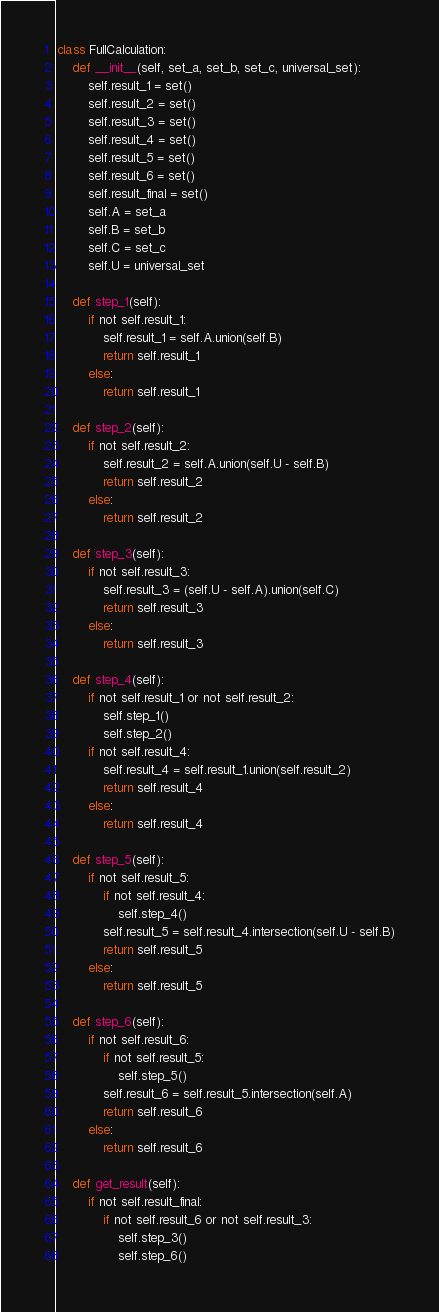Convert code to text. <code><loc_0><loc_0><loc_500><loc_500><_Python_>class FullCalculation:
    def __init__(self, set_a, set_b, set_c, universal_set):
        self.result_1 = set()
        self.result_2 = set()
        self.result_3 = set()
        self.result_4 = set()
        self.result_5 = set()
        self.result_6 = set()
        self.result_final = set()
        self.A = set_a
        self.B = set_b
        self.C = set_c
        self.U = universal_set

    def step_1(self):
        if not self.result_1:
            self.result_1 = self.A.union(self.B)
            return self.result_1
        else:
            return self.result_1

    def step_2(self):
        if not self.result_2:
            self.result_2 = self.A.union(self.U - self.B)
            return self.result_2
        else:
            return self.result_2

    def step_3(self):
        if not self.result_3:
            self.result_3 = (self.U - self.A).union(self.C)
            return self.result_3
        else:
            return self.result_3

    def step_4(self):
        if not self.result_1 or not self.result_2:
            self.step_1()
            self.step_2()
        if not self.result_4:
            self.result_4 = self.result_1.union(self.result_2)
            return self.result_4
        else:
            return self.result_4

    def step_5(self):
        if not self.result_5:
            if not self.result_4:
                self.step_4()
            self.result_5 = self.result_4.intersection(self.U - self.B)
            return self.result_5
        else:
            return self.result_5

    def step_6(self):
        if not self.result_6:
            if not self.result_5:
                self.step_5()
            self.result_6 = self.result_5.intersection(self.A)
            return self.result_6
        else:
            return self.result_6

    def get_result(self):
        if not self.result_final:
            if not self.result_6 or not self.result_3:
                self.step_3()
                self.step_6()</code> 